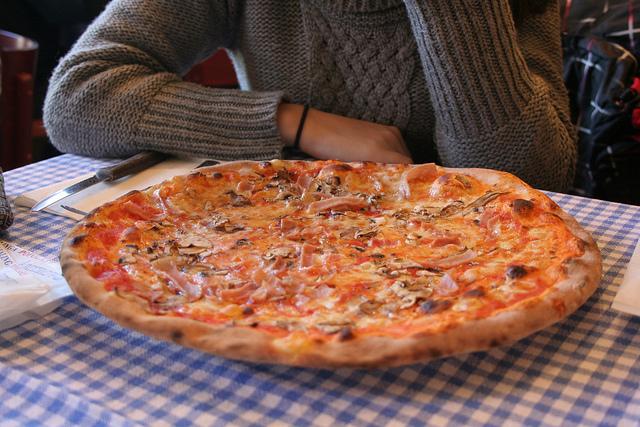What kind pizza is this?
Answer briefly. Ham. What is on the woman's wrist?
Be succinct. Hair tie. What color is the tablecloth?
Concise answer only. Blue and white. 